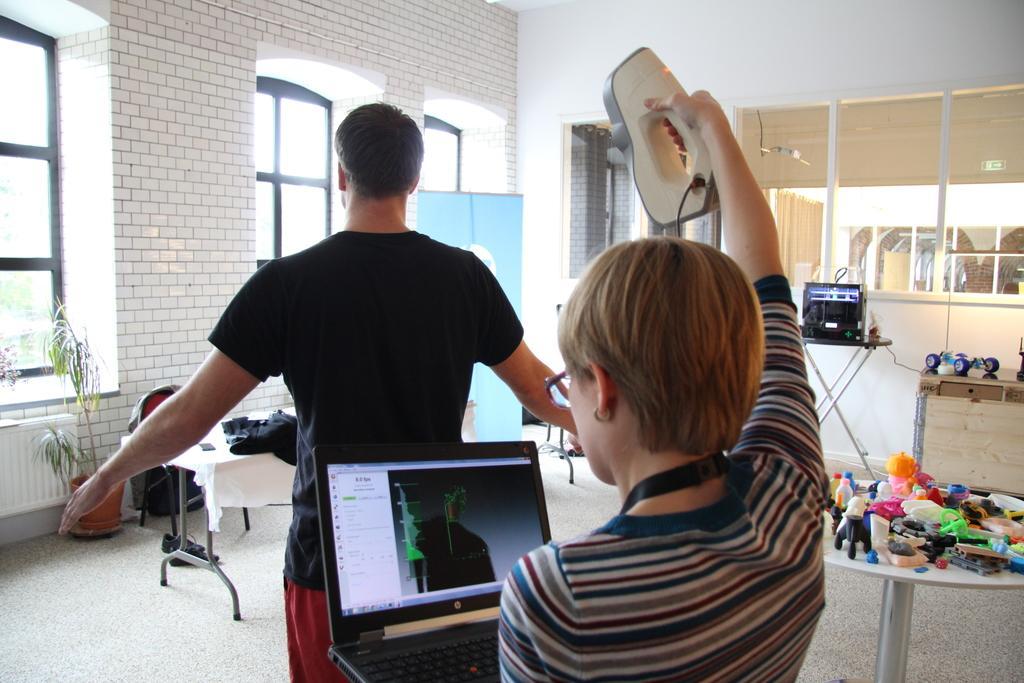In one or two sentences, can you explain what this image depicts? There are two persons in the room one person is holding a laptop and equipment checking another person.
There is one table covered with a cloth and there is a black color cloth kept on this table. There is a house plant kept in room.
There is a wall of bricks and a window in the room. 